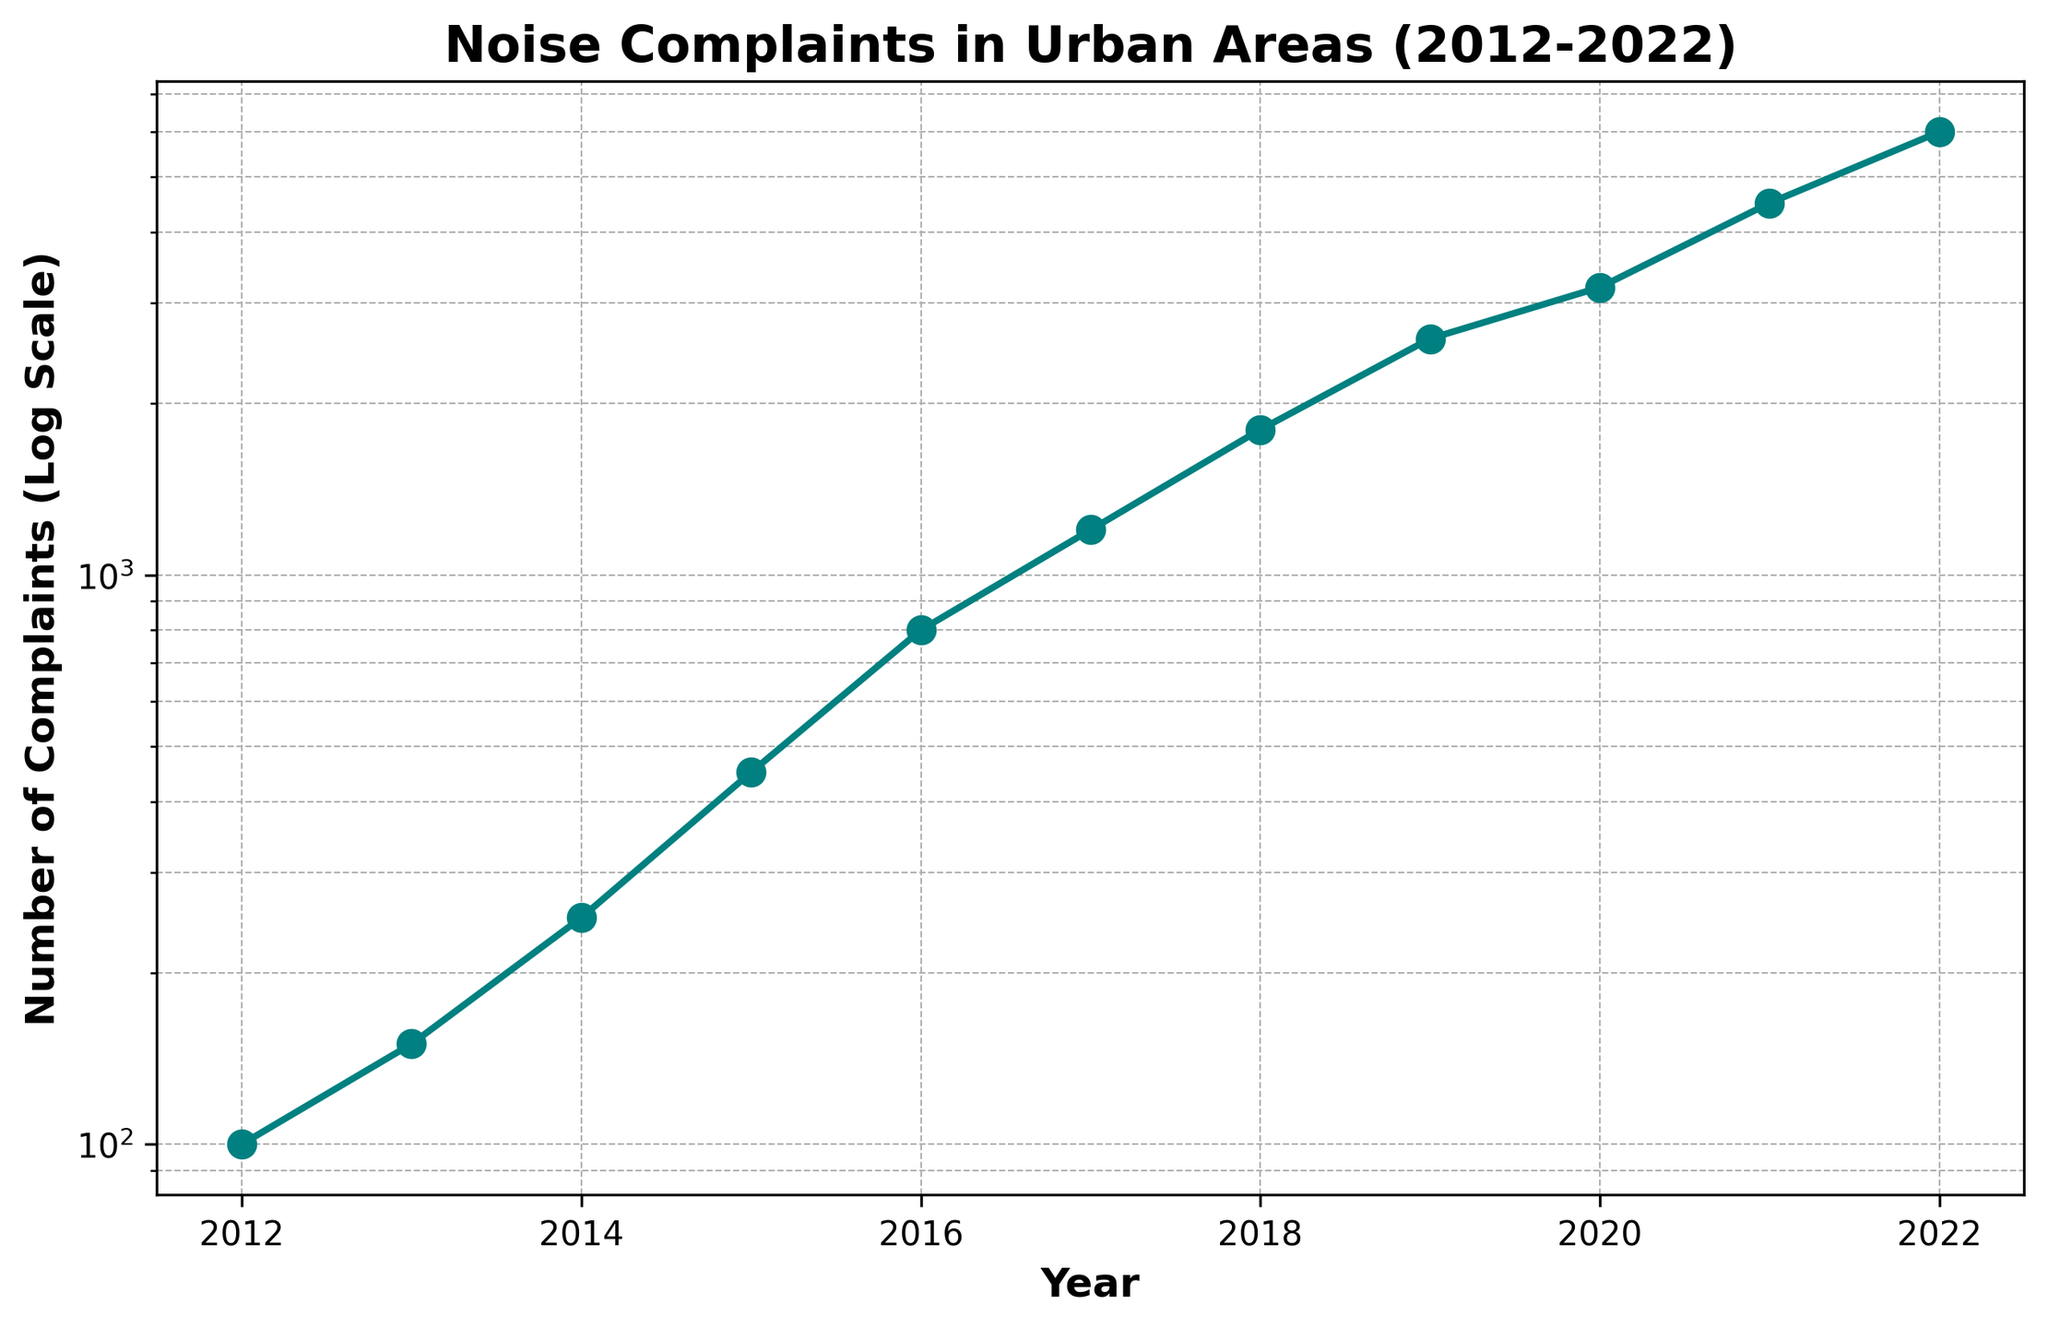What's the overall trend in noise complaints from 2012 to 2022? The line plot shows a continuous increase in the number of noise complaints over the years, as indicated by the upward trajectory of the points from 2012 to 2022.
Answer: An increasing trend Which year had the highest number of noise complaints? By observing the peak point on the graph, the year 2022 has the highest number of noise complaints.
Answer: 2022 How does the number of noise complaints in 2014 compare to 2016? By looking at the y-axis values for 2014 and 2016, 2014 had 250 complaints, and 2016 had 800 complaints, indicating an increase in complaints.
Answer: 2016 had more complaints What is the difference in the number of noise complaints between 2013 and 2015? In 2013, there were 150 complaints, and in 2015, there were 450 complaints. The difference is 450 - 150 = 300 complaints.
Answer: 300 complaints What’s the rate of increase in noise complaints between 2017 and 2021? In 2017, there were 1,200 complaints, and in 2021, there were 4,500 complaints. The rate of increase is (4500 - 1200) / 1200 * 100% = 275%.
Answer: 275% How much did the number of complaints grow from 2012 to 2022? In 2012, there were 100 complaints, and in 2022, there were 6,000 complaints. The growth is 6,000 - 100 = 5,900 complaints.
Answer: 5,900 complaints During which period did the noise complaints increase the most rapidly? By analyzing the slope of the line graph, the steepest slope occurs between 2018 and 2019, indicating the most rapid increase in complaints.
Answer: Between 2018 and 2019 How does the average number of complaints between 2012 and 2014 compare to the average between 2020 and 2022? The average for 2012-2014 is (100+150+250)/3 = 166.67. The average for 2020-2022 is (3200+4500+6000)/3 = 4566.67. Clearly, 4566.67 is much greater than 166.67.
Answer: 2020-2022 had a higher average What does the logarithmic scale indicate about the increase in complaints over time? A logarithmic scale shows that the growth in the number of complaints is exponential rather than linear, with larger increases in later years.
Answer: Exponential growth 